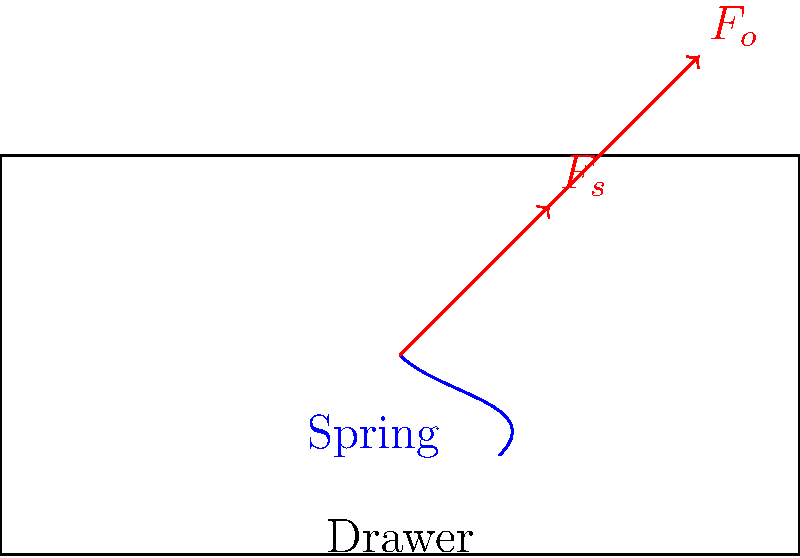In the automated cash register drawer system shown, a spring mechanism is used to assist in opening the drawer. If the spring force ($F_s$) is 15 N and acts at a 45° angle to the horizontal, what minimum external force ($F_o$) is required to open the drawer, assuming the coefficient of friction between the drawer and its housing is 0.2 and the drawer's mass is 2 kg? To solve this problem, we'll follow these steps:

1. Identify the forces acting on the drawer:
   - Spring force ($F_s$): 15 N at 45°
   - External force ($F_o$): unknown, to be calculated
   - Friction force ($F_f$): to be calculated
   - Weight of the drawer ($W$): to be calculated

2. Calculate the weight of the drawer:
   $W = mg = 2 \text{ kg} \times 9.8 \text{ m/s}^2 = 19.6 \text{ N}$

3. Calculate the normal force, which is equal to the weight:
   $N = W = 19.6 \text{ N}$

4. Calculate the maximum friction force:
   $F_f = \mu N = 0.2 \times 19.6 \text{ N} = 3.92 \text{ N}$

5. Resolve the spring force into horizontal and vertical components:
   $F_{sx} = F_s \cos 45° = 15 \text{ N} \times \frac{\sqrt{2}}{2} = 10.61 \text{ N}$
   $F_{sy} = F_s \sin 45° = 15 \text{ N} \times \frac{\sqrt{2}}{2} = 10.61 \text{ N}$

6. Set up the force balance equation in the horizontal direction:
   $F_o + F_{sx} = F_f$

7. Solve for $F_o$:
   $F_o = F_f - F_{sx} = 3.92 \text{ N} - 10.61 \text{ N} = -6.69 \text{ N}$

8. The negative result indicates that the spring force is actually greater than the friction force, meaning no external force is required to open the drawer. The minimum external force is therefore 0 N.
Answer: 0 N 